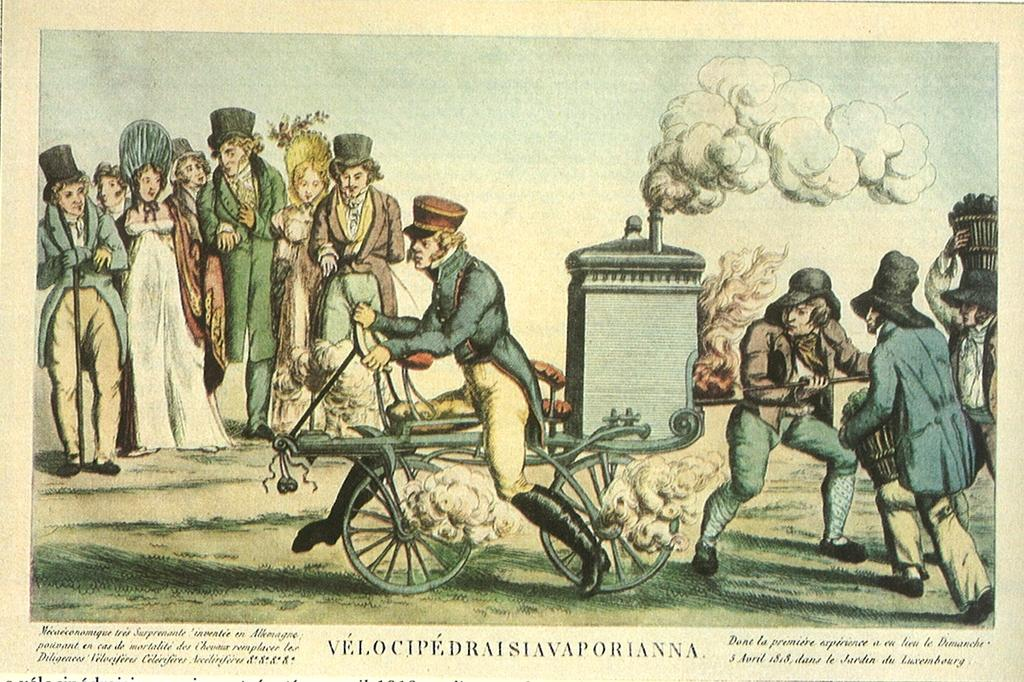What is depicted in the image? There is a picture of a paper in the image. What can be seen on the paper? The paper contains a group of people, a vehicle, and smoke. What is located at the bottom of the image? There is text at the bottom of the image. Are there any volcanoes visible in the image? No, there are no volcanoes present in the image. What type of appliance can be seen in the image? There is no appliance depicted in the image. 